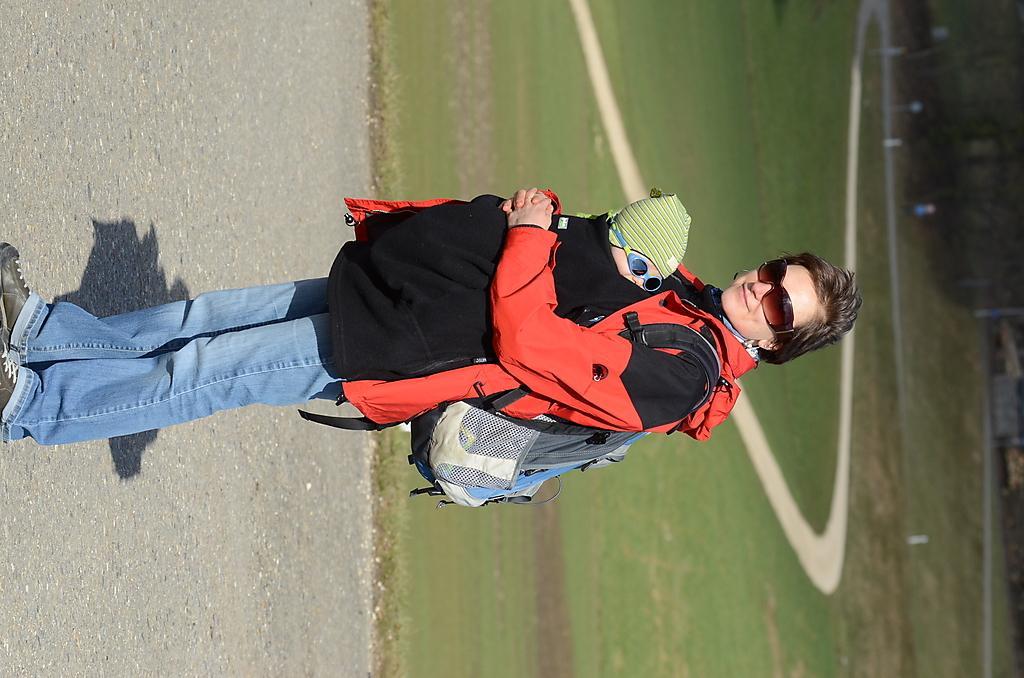Could you give a brief overview of what you see in this image? Here in this picture we can see a lady holding her baby, both of them are wearing goggles, behind them there is a ground 